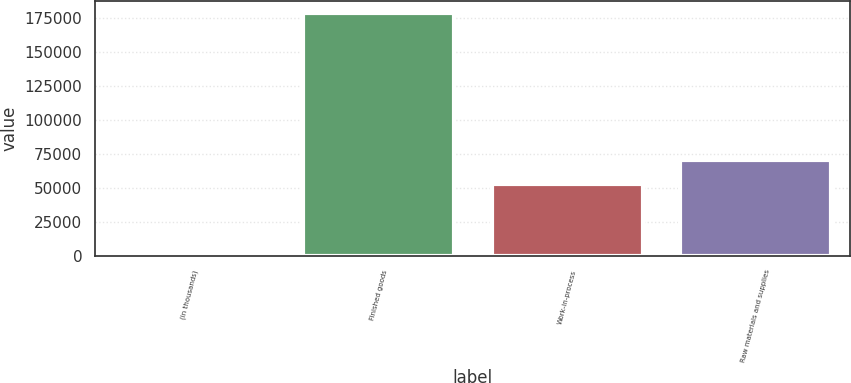Convert chart to OTSL. <chart><loc_0><loc_0><loc_500><loc_500><bar_chart><fcel>(in thousands)<fcel>Finished goods<fcel>Work-in-process<fcel>Raw materials and supplies<nl><fcel>2009<fcel>178721<fcel>53056<fcel>70727.2<nl></chart> 